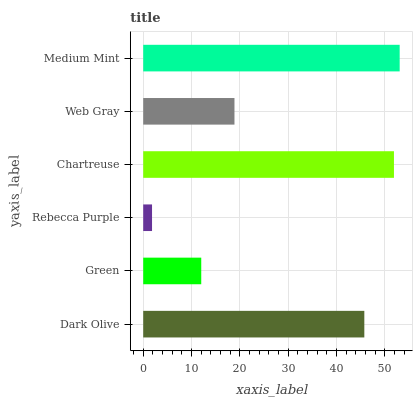Is Rebecca Purple the minimum?
Answer yes or no. Yes. Is Medium Mint the maximum?
Answer yes or no. Yes. Is Green the minimum?
Answer yes or no. No. Is Green the maximum?
Answer yes or no. No. Is Dark Olive greater than Green?
Answer yes or no. Yes. Is Green less than Dark Olive?
Answer yes or no. Yes. Is Green greater than Dark Olive?
Answer yes or no. No. Is Dark Olive less than Green?
Answer yes or no. No. Is Dark Olive the high median?
Answer yes or no. Yes. Is Web Gray the low median?
Answer yes or no. Yes. Is Chartreuse the high median?
Answer yes or no. No. Is Medium Mint the low median?
Answer yes or no. No. 